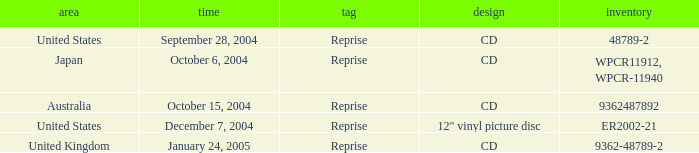What is the catalogue on october 15, 2004? 9362487892.0. 